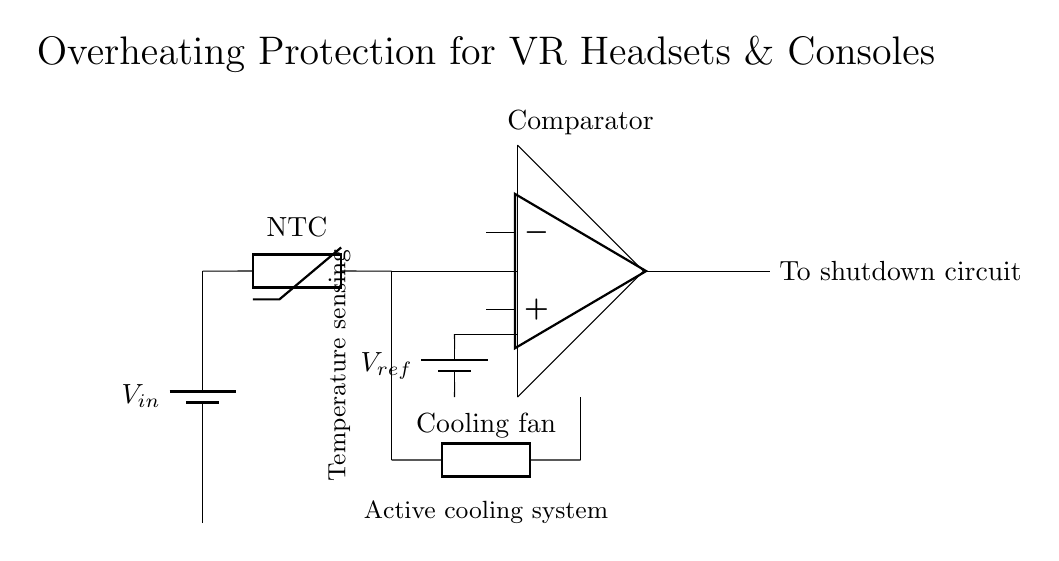What is the primary function of the thermistor in this circuit? The thermistor serves as a temperature sensing component; it detects the ambient temperature within the VR headset or console. This allows the circuit to monitor overheating conditions and take appropriate action.
Answer: Temperature sensing What component provides the reference voltage in this circuit? A reference voltage is provided by a battery, specifically indicated as V_ref. This voltage helps in comparing the thermistor's output voltage to determine if overheating occurs.
Answer: Battery What triggers the shutdown circuit in this design? The shutdown circuit is triggered by the output from the comparator, which is connected after the thermistor input. If the thermistor detects a temperature above a certain threshold, the comparator sends a signal to initiate shutdown.
Answer: Comparator output What type of cooling system is used in this protection circuit? The protection circuit utilizes an active cooling system that is represented by a cooling fan in the diagram. This fan activates when the thermistor detects an increased temperature, thereby helping to cool the device.
Answer: Cooling fan How many main components are visually identified in this circuit diagram? The diagram includes four main components: a battery (V_in), a thermistor, a comparator, and a cooling fan. Noting their distinct functions, they work together for overheating protection.
Answer: Four What configuration is used to connect the comparator's inputs in this circuit? The inputs of the comparator are connected in a differential configuration, where one input receives the thermistor output and the other receives the reference voltage. This setup allows for effective comparison of the two voltage levels.
Answer: Differential configuration 